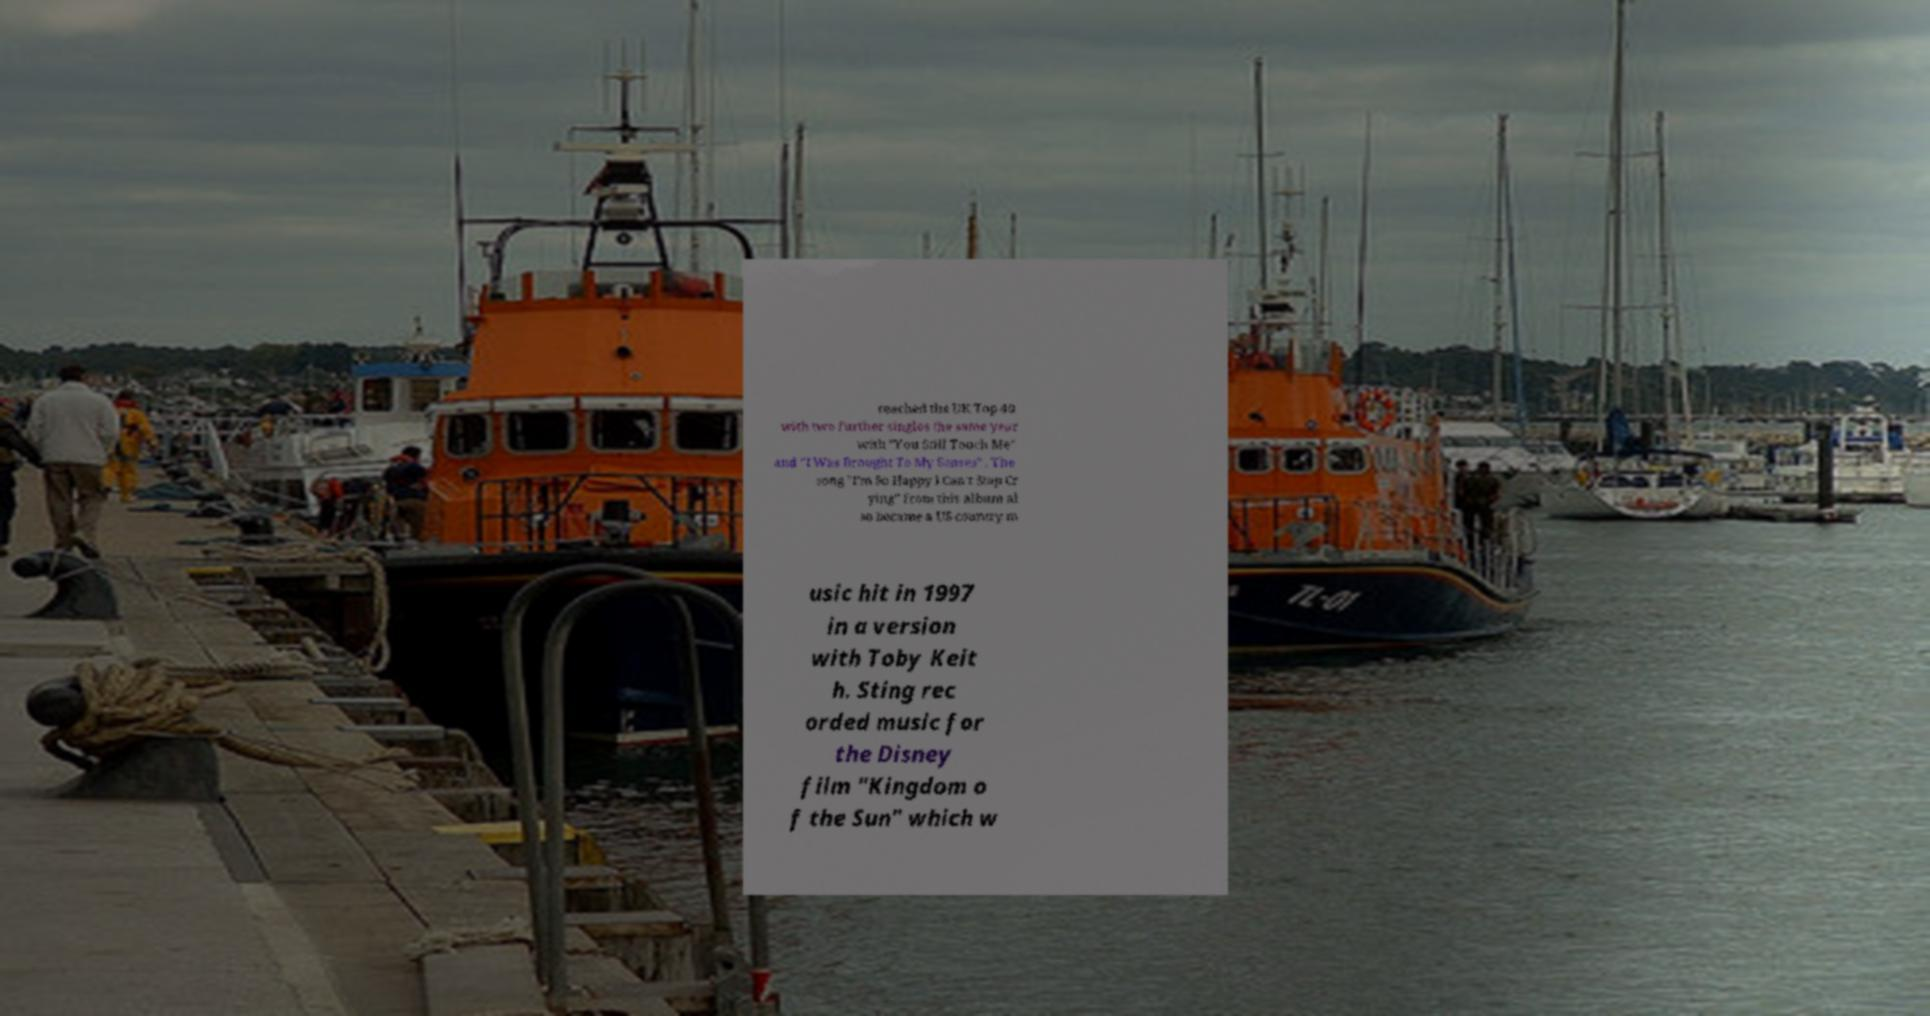Can you read and provide the text displayed in the image?This photo seems to have some interesting text. Can you extract and type it out for me? reached the UK Top 40 with two further singles the same year with "You Still Touch Me" and "I Was Brought To My Senses" . The song "I'm So Happy I Can't Stop Cr ying" from this album al so became a US country m usic hit in 1997 in a version with Toby Keit h. Sting rec orded music for the Disney film "Kingdom o f the Sun" which w 